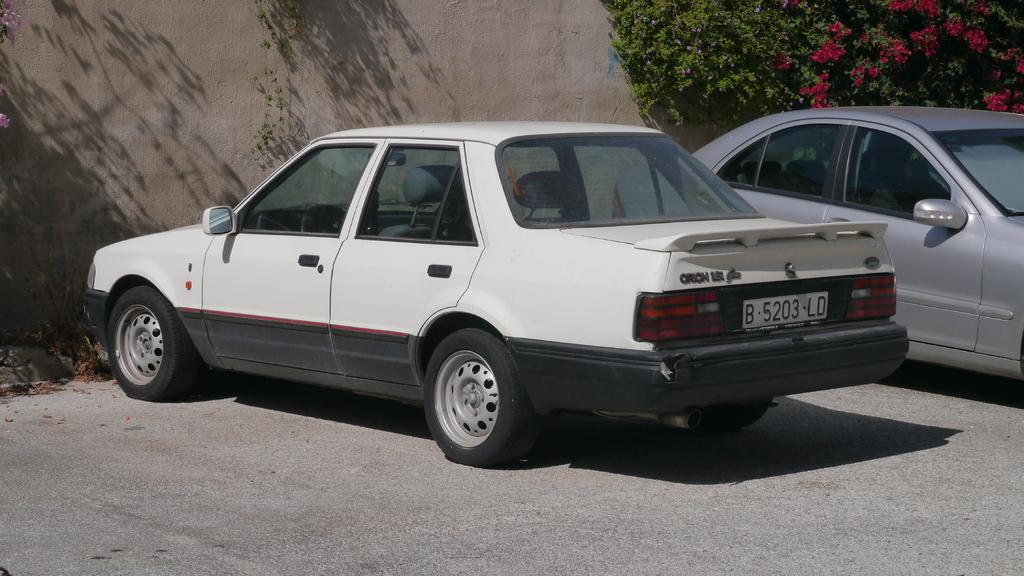How many cars are visible in the image? There are two cars in the image. Where are the cars located? The cars are on the ground. What can be seen in the background of the image? There is a wall and a tree in the background of the image. What type of eggnog is being served from the apparatus in the image? There is no eggnog or apparatus present in the image. 